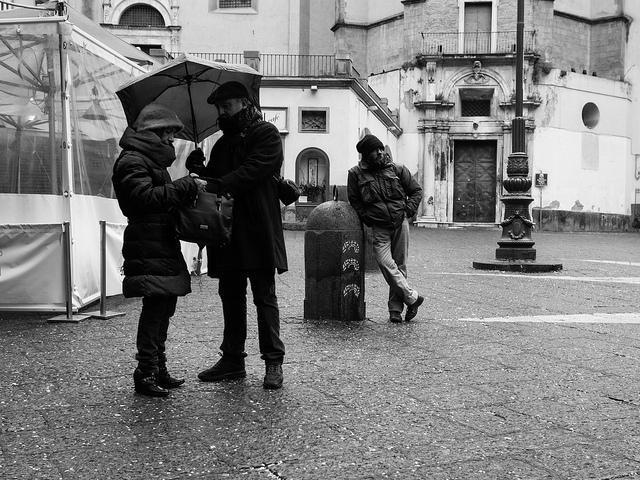How many hold skateboards?
Give a very brief answer. 0. How many handbags are there?
Give a very brief answer. 1. How many people can be seen?
Give a very brief answer. 3. How many zebras are there?
Give a very brief answer. 0. 